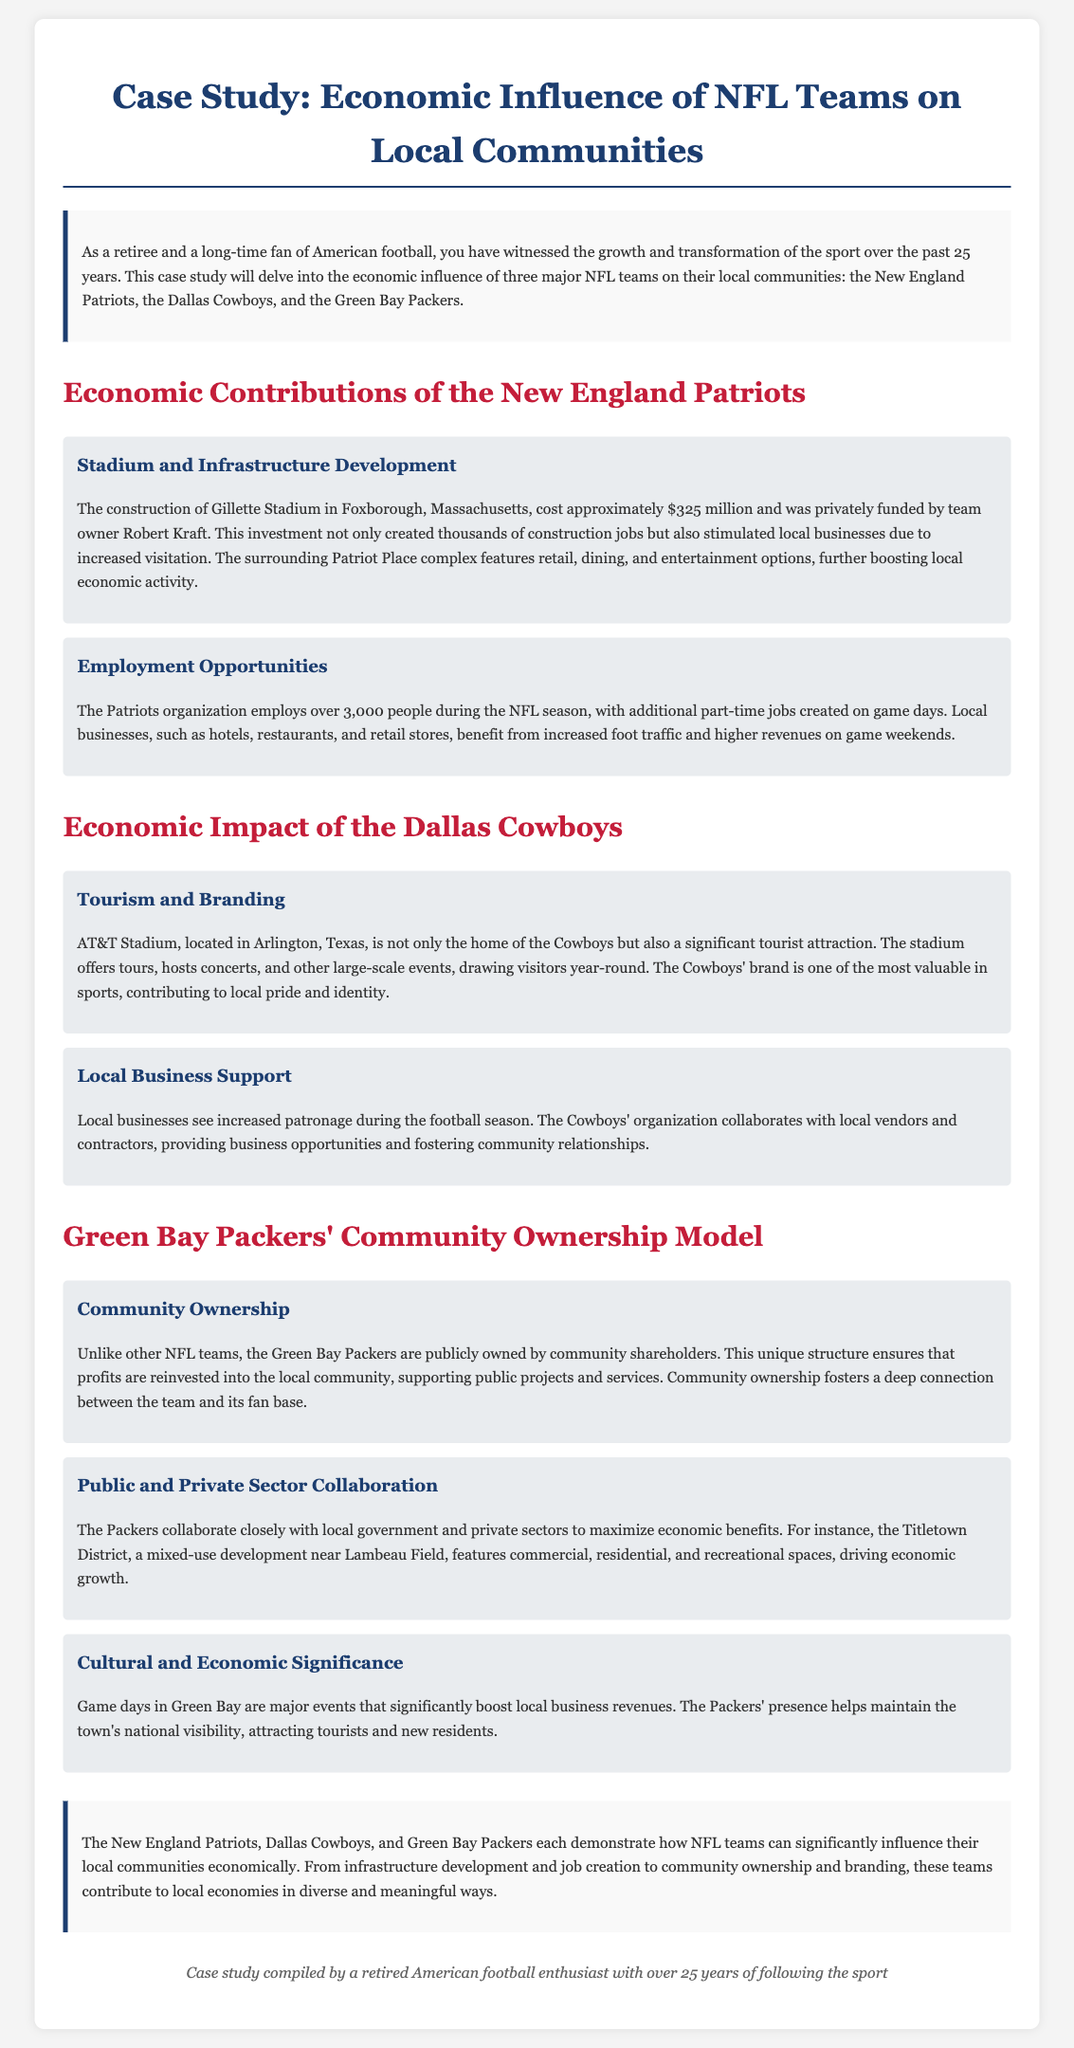what is the construction cost of Gillette Stadium? The document states that Gillette Stadium cost approximately $325 million to construct.
Answer: $325 million how many people does the Patriots organization employ during the NFL season? The document mentions that the Patriots organization employs over 3,000 people during the NFL season.
Answer: over 3,000 what is a significant tourist attraction in Arlington, Texas? The document notes that AT&T Stadium is a significant tourist attraction in Arlington, Texas.
Answer: AT&T Stadium what unique ownership model do the Green Bay Packers have? The document describes the Packers as being publicly owned by community shareholders, which is a unique ownership model.
Answer: community shareholders what development is mentioned near Lambeau Field? The document refers to the Titletown District as a mixed-use development near Lambeau Field.
Answer: Titletown District how do the Cowboys support local businesses? The document states that the Cowboys' organization collaborates with local vendors and contractors to provide business opportunities.
Answer: collaborate with local vendors and contractors which NFL team's profits are reinvested into the local community? The document mentions that the Green Bay Packers reinvest profits into the local community due to their ownership structure.
Answer: Green Bay Packers what kind of events significantly boost local business revenues in Green Bay? The document indicates that game days are major events that boost local business revenues in Green Bay.
Answer: game days 